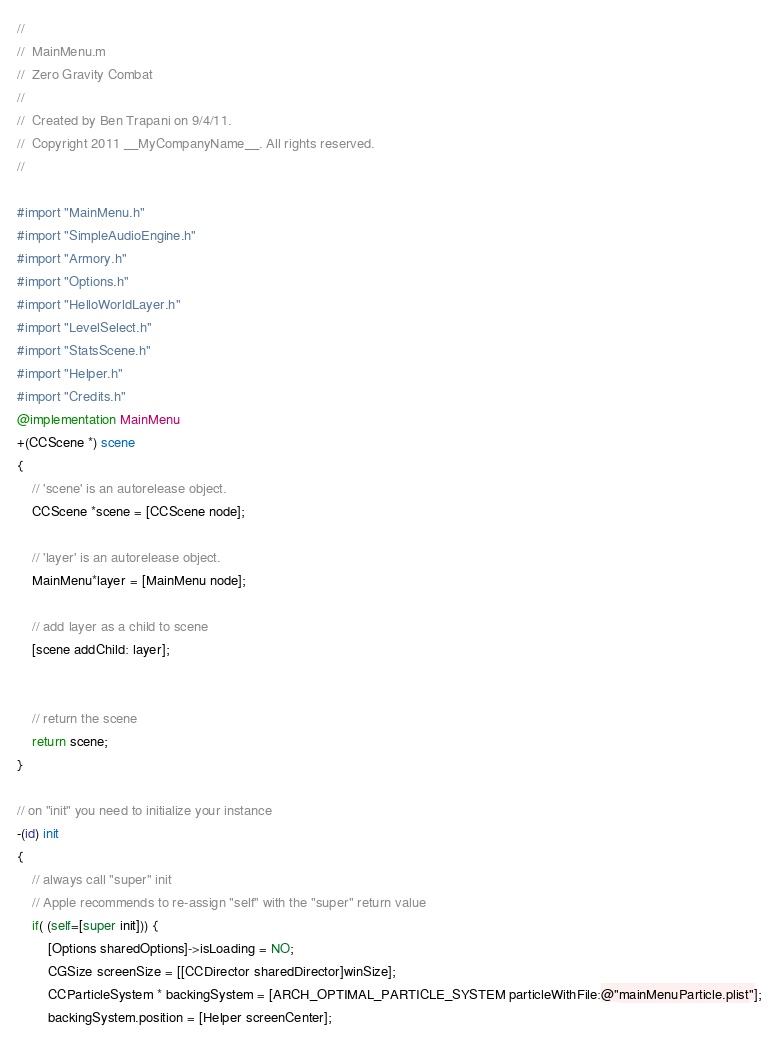<code> <loc_0><loc_0><loc_500><loc_500><_ObjectiveC_>//
//  MainMenu.m
//  Zero Gravity Combat
//
//  Created by Ben Trapani on 9/4/11.
//  Copyright 2011 __MyCompanyName__. All rights reserved.
//

#import "MainMenu.h"
#import "SimpleAudioEngine.h"
#import "Armory.h"
#import "Options.h"
#import "HelloWorldLayer.h"
#import "LevelSelect.h"
#import "StatsScene.h"
#import "Helper.h"
#import "Credits.h"
@implementation MainMenu
+(CCScene *) scene
{
	// 'scene' is an autorelease object.
	CCScene *scene = [CCScene node];
	
	// 'layer' is an autorelease object.
	MainMenu*layer = [MainMenu node];
	
	// add layer as a child to scene
	[scene addChild: layer];
	
	
	// return the scene
	return scene;
}

// on "init" you need to initialize your instance
-(id) init
{
	// always call "super" init
	// Apple recommends to re-assign "self" with the "super" return value
	if( (self=[super init])) {
        [Options sharedOptions]->isLoading = NO;
		CGSize screenSize = [[CCDirector sharedDirector]winSize];
		CCParticleSystem * backingSystem = [ARCH_OPTIMAL_PARTICLE_SYSTEM particleWithFile:@"mainMenuParticle.plist"];
        backingSystem.position = [Helper screenCenter];</code> 